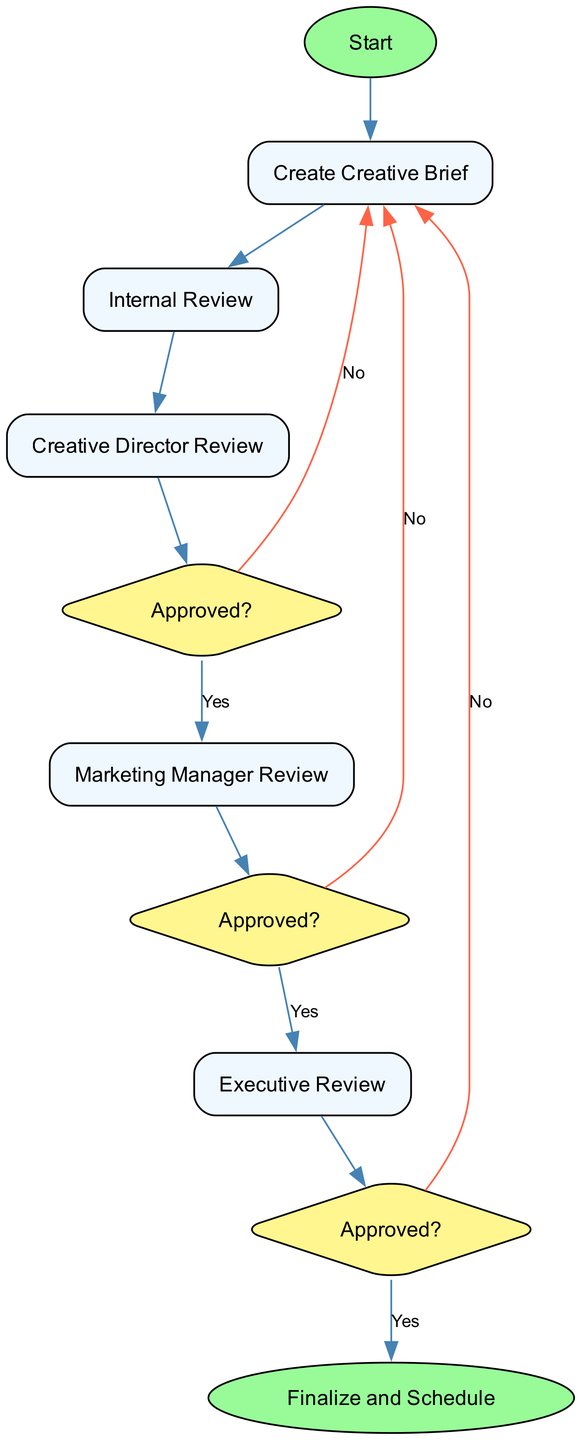What is the first step in the approval workflow? The first step in the approval workflow is to create the creative brief, as indicated in the diagram where it transitions from the "Start" node to the "Create Creative Brief" node.
Answer: Create Creative Brief How many stages are there in the approval process? The approval process includes three stages, which are represented as "Stage1," "Stage2," and "Stage3" in the diagram.
Answer: Three What is the decision point after the Creative Director's review? The decision point after the Creative Director's review is whether the brief is "Approved?" as indicated by the diamond-shaped node that follows the review process.
Answer: Approved? What happens if the Marketing Manager needs revisions? If revisions are needed after the Marketing Manager's review, the workflow directs back to the "Create Creative Brief" node, indicating the need for a revision cycle.
Answer: Revise based on feedback What does the process conclude with if the Executive approves the final brief? If the Executive approves the final brief, the process concludes with the node that indicates finalization and scheduling for production, as shown at the end of the workflow.
Answer: Finalize and Schedule What will happen if the Creative Director decides revisions are needed? If the Creative Director decides revisions are needed, the workflow indicates that it loops back to the "Create Creative Brief" node, signifying that the writer must revise the brief before resubmission.
Answer: Revise based on feedback What is the last review stage in the approval workflow? The last review stage in the approval workflow is the Executive Review, which is the final step before the creative brief can be approved or rejected.
Answer: Executive Review How many decisions are made throughout the approval workflow? There are three decision points in the approval workflow: one each after the Creative Director's review, the Marketing Manager's review, and the Executive's review.
Answer: Three 